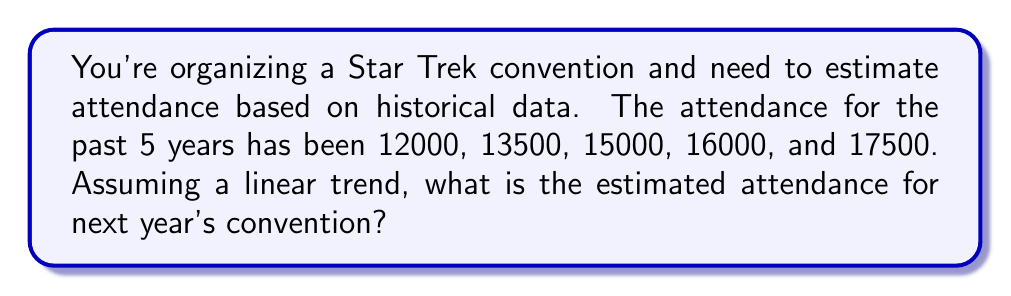What is the answer to this math problem? To estimate the attendance for next year's convention, we'll use a linear regression model based on the historical data. Let's follow these steps:

1. Assign years to the data points:
   Year 1: 12000
   Year 2: 13500
   Year 3: 15000
   Year 4: 16000
   Year 5: 17500

2. Calculate the slope (m) of the linear trend:
   $$m = \frac{n\sum xy - \sum x \sum y}{n\sum x^2 - (\sum x)^2}$$
   
   Where:
   n = 5 (number of data points)
   x = years (1, 2, 3, 4, 5)
   y = attendance values

   $$\sum x = 1 + 2 + 3 + 4 + 5 = 15$$
   $$\sum y = 12000 + 13500 + 15000 + 16000 + 17500 = 74000$$
   $$\sum xy = 1(12000) + 2(13500) + 3(15000) + 4(16000) + 5(17500) = 281000$$
   $$\sum x^2 = 1^2 + 2^2 + 3^2 + 4^2 + 5^2 = 55$$

   $$m = \frac{5(281000) - 15(74000)}{5(55) - 15^2} = \frac{1405000 - 1110000}{275 - 225} = \frac{295000}{50} = 5900$$

3. Calculate the y-intercept (b):
   $$b = \frac{\sum y - m\sum x}{n}$$
   
   $$b = \frac{74000 - 5900(15)}{5} = \frac{74000 - 88500}{5} = -2900$$

4. The linear equation is:
   $$y = mx + b = 5900x - 2900$$

5. To estimate attendance for next year (Year 6), substitute x = 6:
   $$y = 5900(6) - 2900 = 35400 - 2900 = 32500$$

Therefore, the estimated attendance for next year's convention is 32,500 people.
Answer: 32,500 attendees 